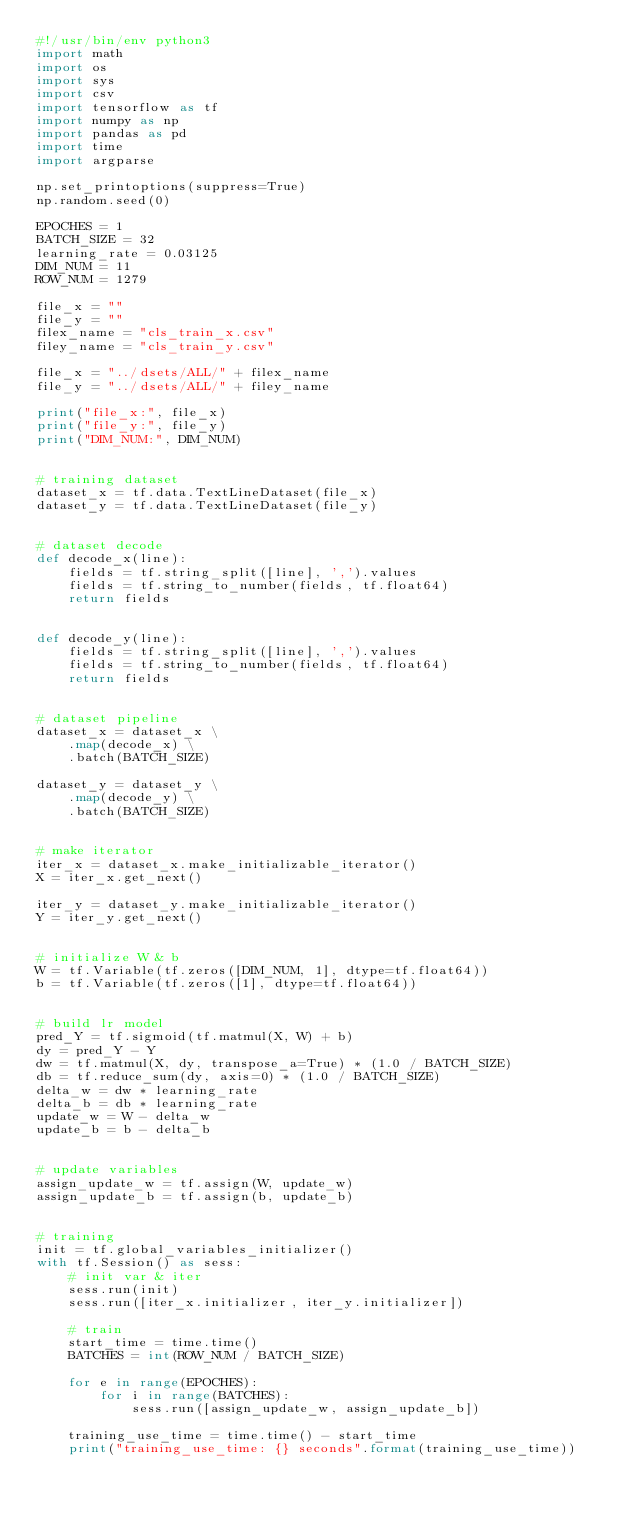Convert code to text. <code><loc_0><loc_0><loc_500><loc_500><_Python_>#!/usr/bin/env python3
import math
import os
import sys
import csv
import tensorflow as tf
import numpy as np
import pandas as pd
import time
import argparse

np.set_printoptions(suppress=True)
np.random.seed(0)

EPOCHES = 1
BATCH_SIZE = 32
learning_rate = 0.03125
DIM_NUM = 11
ROW_NUM = 1279

file_x = ""
file_y = ""
filex_name = "cls_train_x.csv"
filey_name = "cls_train_y.csv"

file_x = "../dsets/ALL/" + filex_name
file_y = "../dsets/ALL/" + filey_name

print("file_x:", file_x)
print("file_y:", file_y)
print("DIM_NUM:", DIM_NUM)


# training dataset
dataset_x = tf.data.TextLineDataset(file_x)
dataset_y = tf.data.TextLineDataset(file_y)


# dataset decode
def decode_x(line):
    fields = tf.string_split([line], ',').values
    fields = tf.string_to_number(fields, tf.float64)
    return fields


def decode_y(line):
    fields = tf.string_split([line], ',').values
    fields = tf.string_to_number(fields, tf.float64)
    return fields


# dataset pipeline
dataset_x = dataset_x \
    .map(decode_x) \
    .batch(BATCH_SIZE)

dataset_y = dataset_y \
    .map(decode_y) \
    .batch(BATCH_SIZE)


# make iterator
iter_x = dataset_x.make_initializable_iterator()
X = iter_x.get_next()

iter_y = dataset_y.make_initializable_iterator()
Y = iter_y.get_next()


# initialize W & b
W = tf.Variable(tf.zeros([DIM_NUM, 1], dtype=tf.float64))
b = tf.Variable(tf.zeros([1], dtype=tf.float64))


# build lr model
pred_Y = tf.sigmoid(tf.matmul(X, W) + b)
dy = pred_Y - Y
dw = tf.matmul(X, dy, transpose_a=True) * (1.0 / BATCH_SIZE)
db = tf.reduce_sum(dy, axis=0) * (1.0 / BATCH_SIZE)
delta_w = dw * learning_rate
delta_b = db * learning_rate
update_w = W - delta_w
update_b = b - delta_b


# update variables
assign_update_w = tf.assign(W, update_w)
assign_update_b = tf.assign(b, update_b)


# training
init = tf.global_variables_initializer()
with tf.Session() as sess:
    # init var & iter
    sess.run(init)
    sess.run([iter_x.initializer, iter_y.initializer])

    # train
    start_time = time.time()
    BATCHES = int(ROW_NUM / BATCH_SIZE)

    for e in range(EPOCHES):
        for i in range(BATCHES):
            sess.run([assign_update_w, assign_update_b])

    training_use_time = time.time() - start_time
    print("training_use_time: {} seconds".format(training_use_time))
</code> 